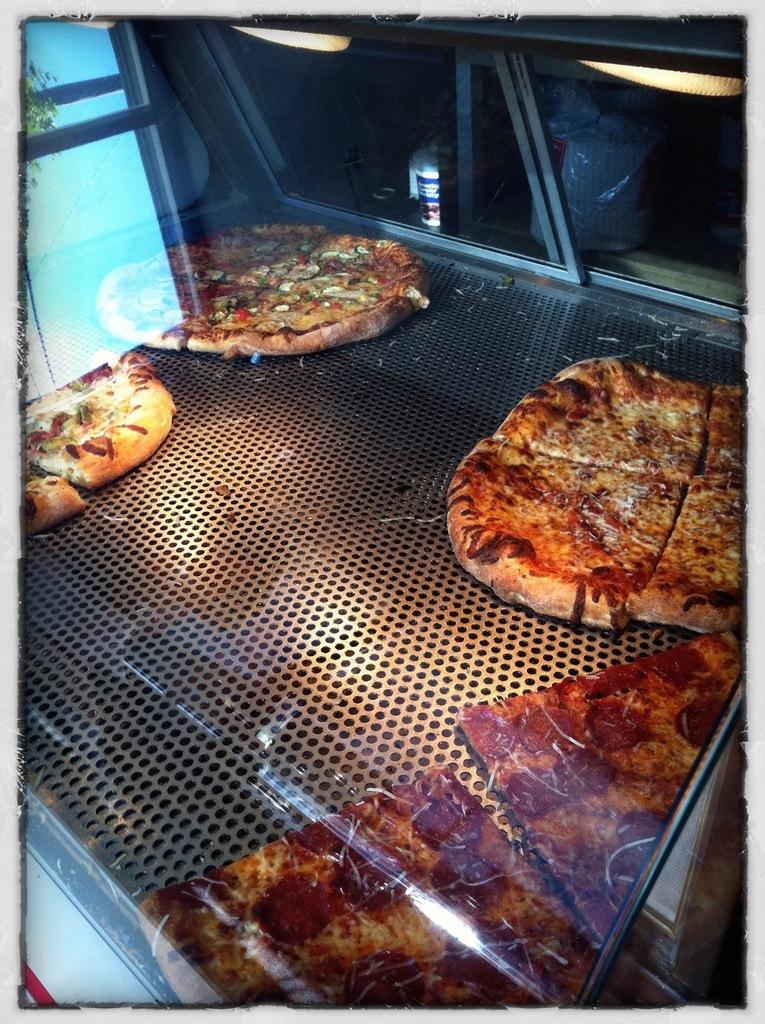What type of food is stored in the glass container in the image? There are pizzas stored in a closed glass container in the image. What can be seen on the right side of the image? There are pieces of pizza on the right side of the image. What color light is present on the left side of the image? There is a blue color light on the left side of the image. What type of squirrel can be seen eating beef in the image? There is no squirrel or beef present in the image; it features pizzas stored in a glass container and pieces of pizza on the right side. 